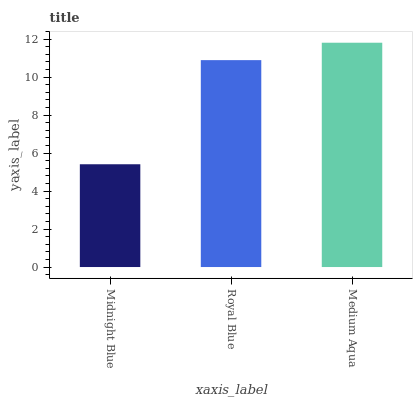Is Royal Blue the minimum?
Answer yes or no. No. Is Royal Blue the maximum?
Answer yes or no. No. Is Royal Blue greater than Midnight Blue?
Answer yes or no. Yes. Is Midnight Blue less than Royal Blue?
Answer yes or no. Yes. Is Midnight Blue greater than Royal Blue?
Answer yes or no. No. Is Royal Blue less than Midnight Blue?
Answer yes or no. No. Is Royal Blue the high median?
Answer yes or no. Yes. Is Royal Blue the low median?
Answer yes or no. Yes. Is Medium Aqua the high median?
Answer yes or no. No. Is Midnight Blue the low median?
Answer yes or no. No. 